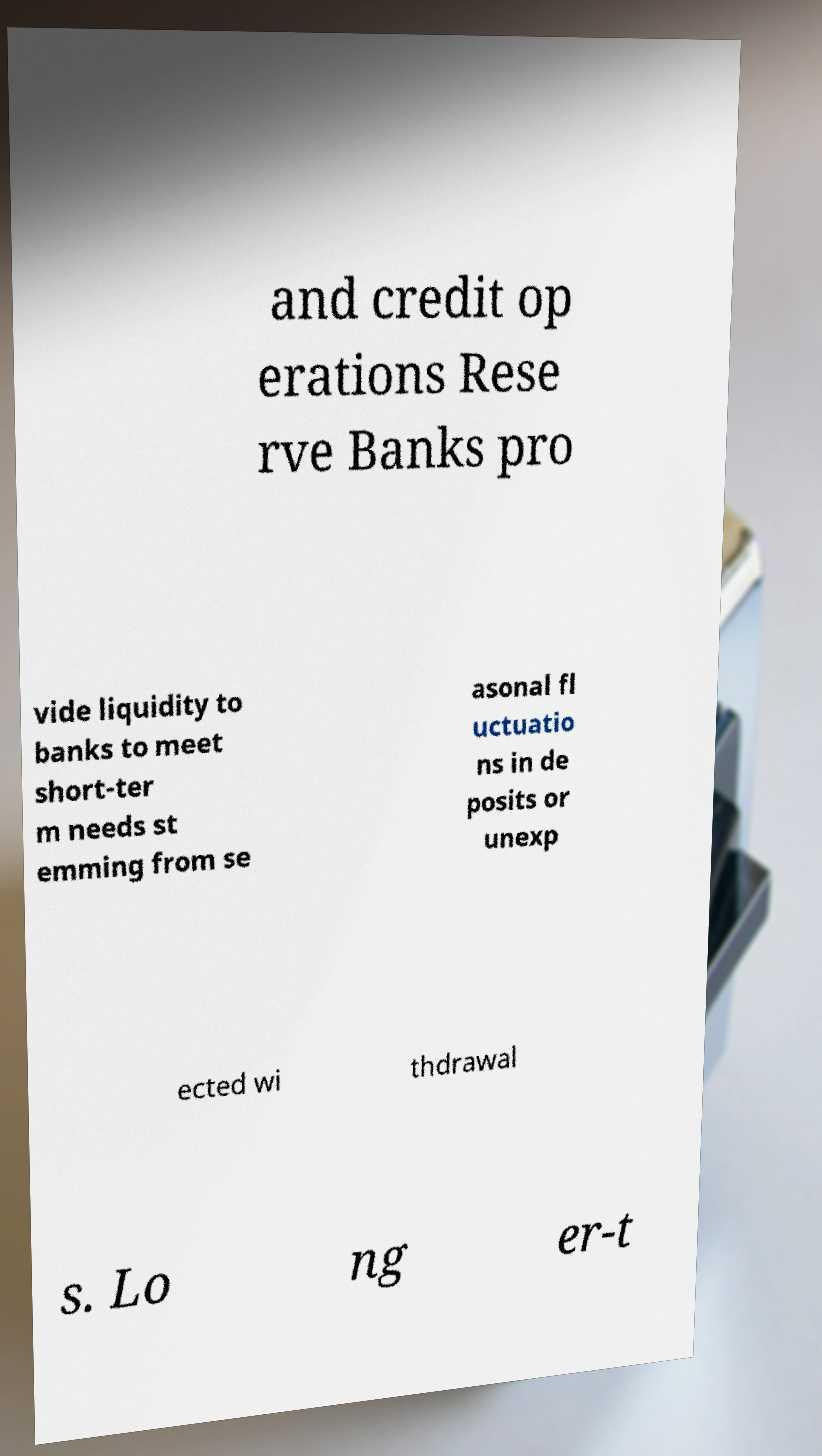For documentation purposes, I need the text within this image transcribed. Could you provide that? and credit op erations Rese rve Banks pro vide liquidity to banks to meet short-ter m needs st emming from se asonal fl uctuatio ns in de posits or unexp ected wi thdrawal s. Lo ng er-t 